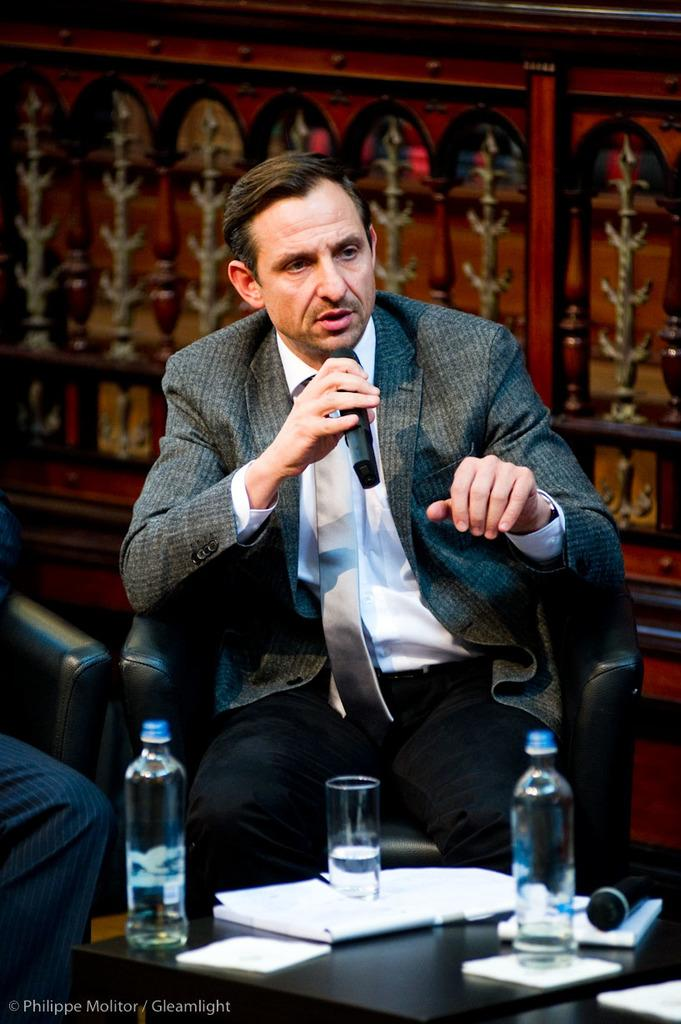What is the man in the image doing? The man is sitting in a chair and holding a microphone in his hand. What is on the table in front of the man? There are water bottles, a glass, and a book on the table. Can you describe the man's activity in the image? The man appears to be engaged in an activity that involves using the microphone, possibly speaking or singing. What type of snow can be seen falling in the image? There is no snow present in the image; it is indoors and the man is sitting in a chair. How many dolls are visible on the table in the image? There are no dolls present in the image; the objects on the table are water bottles, a glass, and a book. 